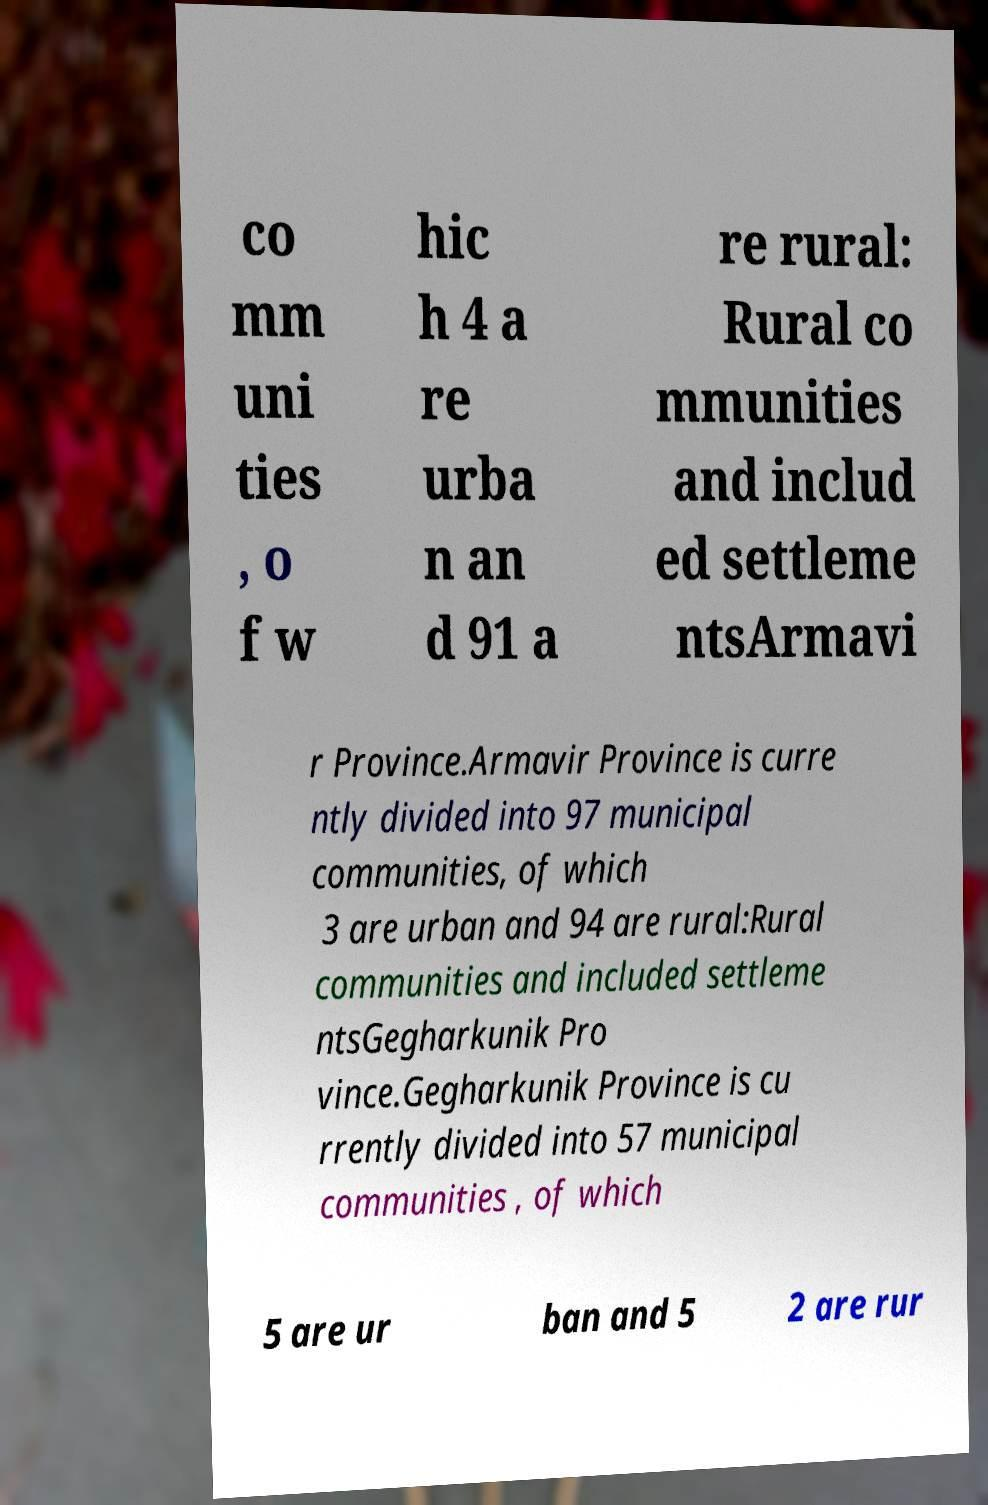Could you assist in decoding the text presented in this image and type it out clearly? co mm uni ties , o f w hic h 4 a re urba n an d 91 a re rural: Rural co mmunities and includ ed settleme ntsArmavi r Province.Armavir Province is curre ntly divided into 97 municipal communities, of which 3 are urban and 94 are rural:Rural communities and included settleme ntsGegharkunik Pro vince.Gegharkunik Province is cu rrently divided into 57 municipal communities , of which 5 are ur ban and 5 2 are rur 